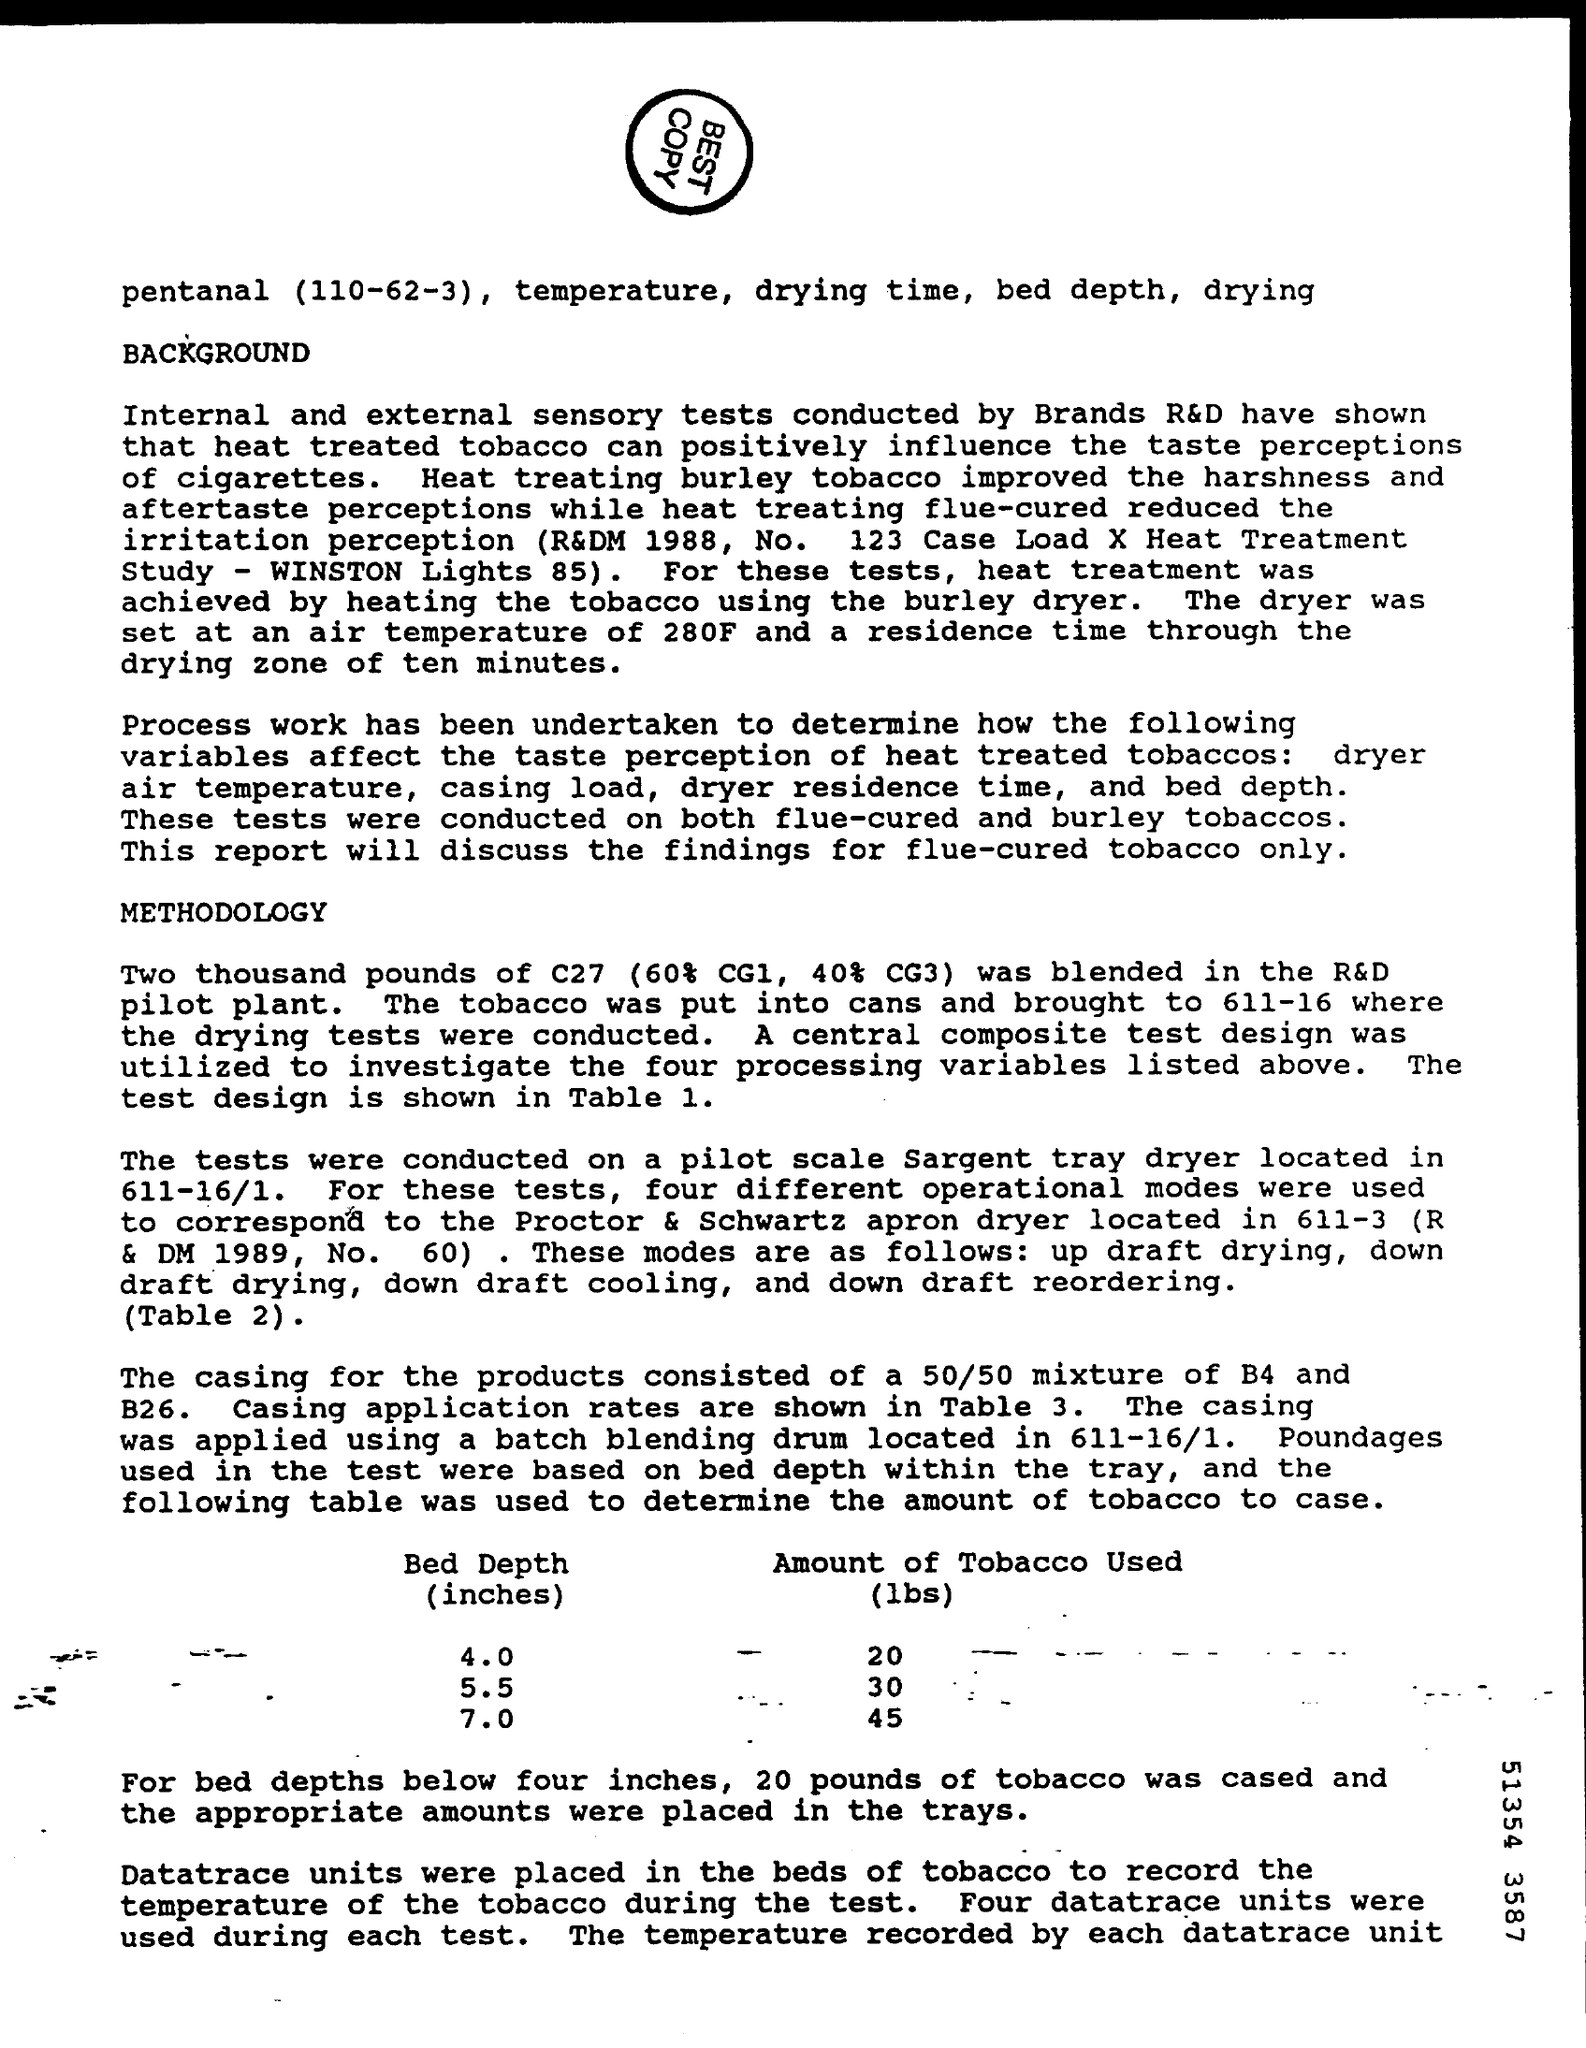Mention a couple of crucial points in this snapshot. The amount of tobacco use for a bed depth of 5.5 inches is 30 pounds. The amount of tobacco use for a bed depth of 7.0 inches is 45 pounds. The amount of tobacco use for a bed depth of 4.0 inches is [insert value]. 